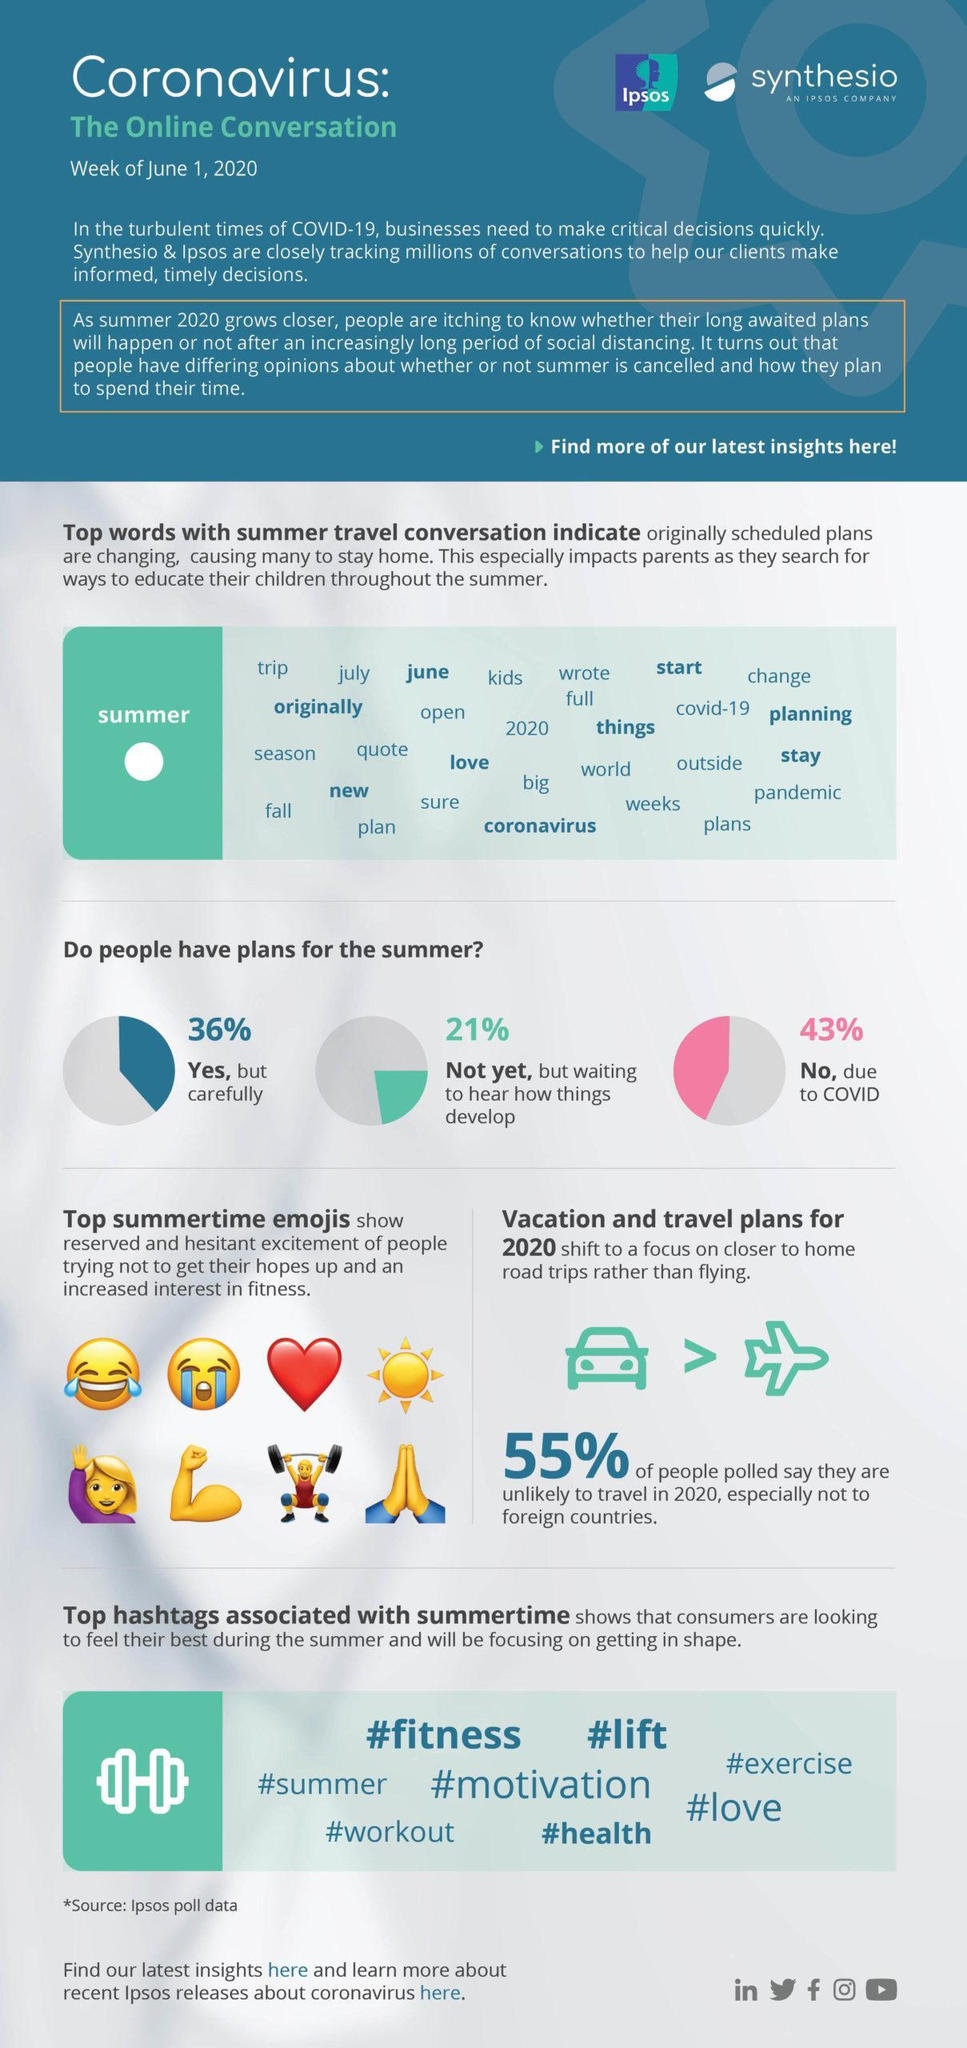How many top summer emojis are shown?
Answer the question with a short phrase. 8 What percent of people haven't yet made any plans for summer? 21% What percentage of people have made no plans for summer? 43% What percentage of the respondents will avoid traveling abroad in 2020? 55% What percentage of people have made plans for summer? 36% 